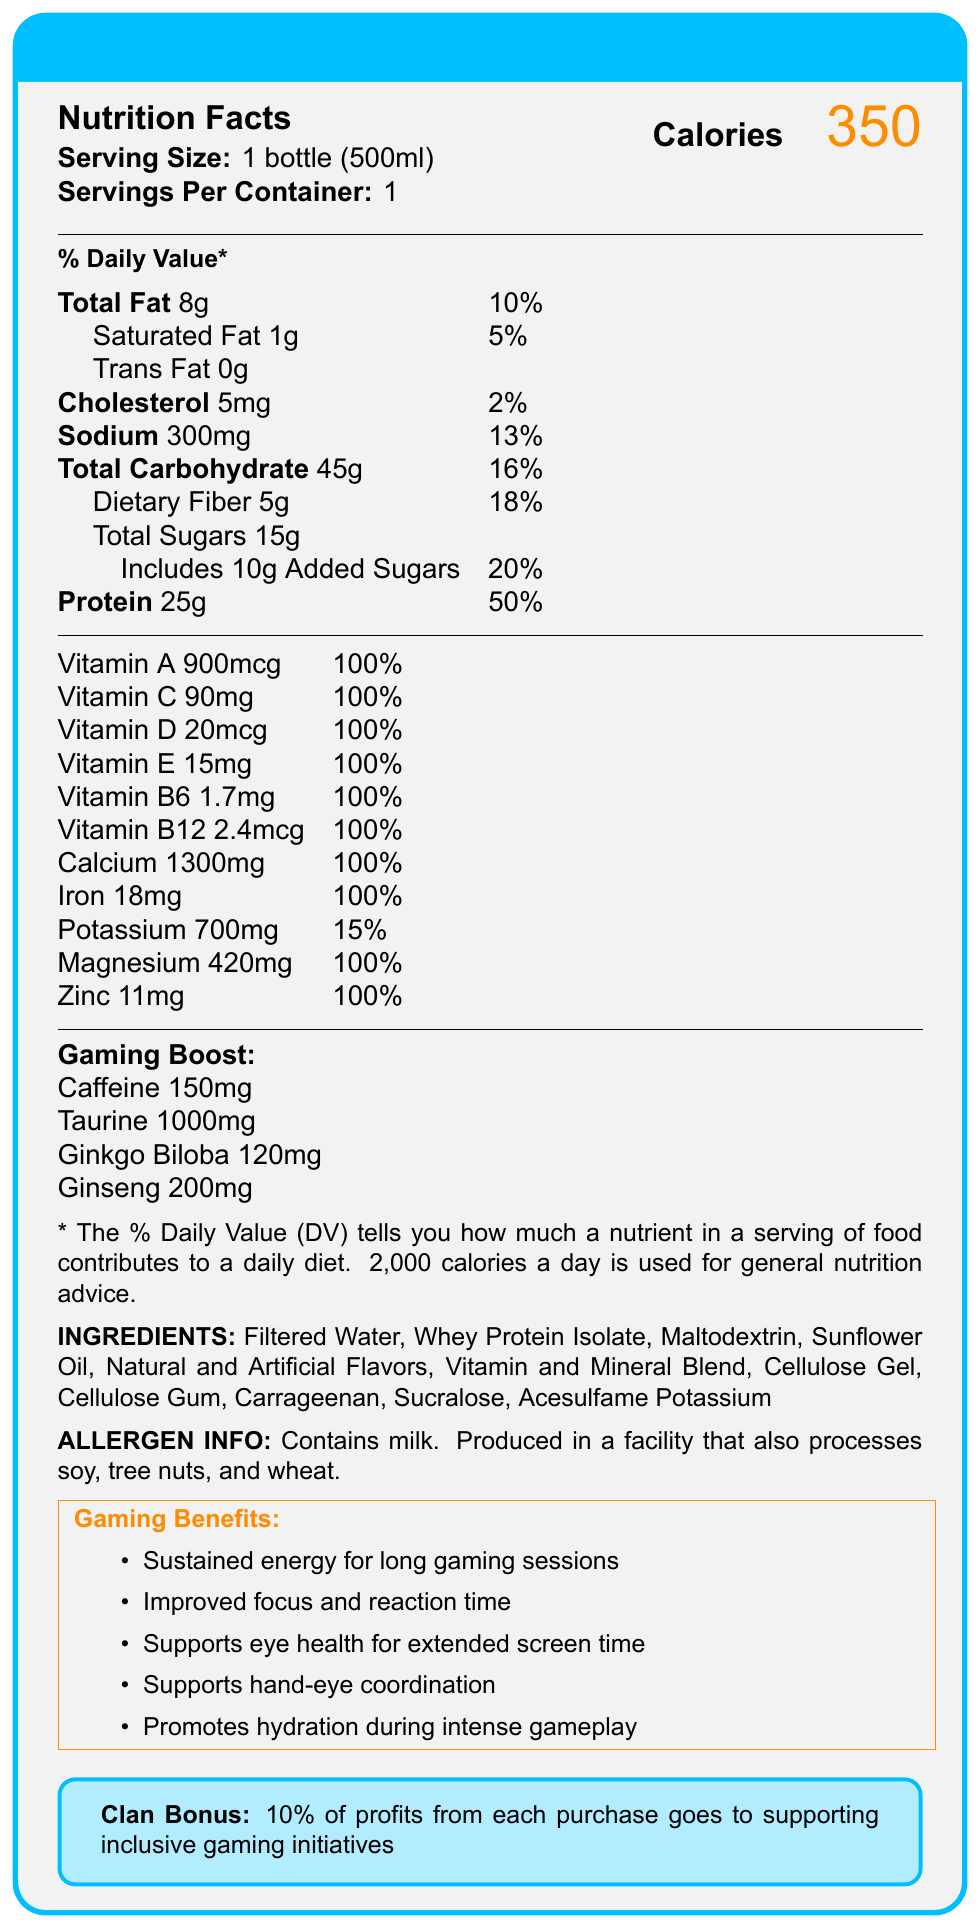what is the product name? The document specifies the product name "GameFuel Ultimate Shake" at the top in the title section.
Answer: GameFuel Ultimate Shake how many calories are in one serving? The document mentions that one serving of GameFuel Ultimate Shake contains 350 calories, highlighted in a large font on the right side.
Answer: 350 what is the serving size of the shake? The serving size is indicated as "1 bottle (500ml)" in the document, under the "Serving Size" section.
Answer: 1 bottle (500ml) how much protein does the shake contain? The document notes that each serving contains 25g of protein, which is 50% of the daily value.
Answer: 25g how much caffeine is in the shake? The shake contains 150mg of caffeine as noted in the "Gaming Boost" section of the document.
Answer: 150mg which vitamin is present at the highest percentage of daily value? A. Vitamin A B. Vitamin C C. Vitamin D D. Vitamin B6 All listed vitamins (A, C, D, E, B6, B12) have 100%, but Vitamin A is the first one listed at 100%.
Answer: A. Vitamin A what are the potential allergens mentioned in the document? A. Soy B. Milk C. Tree nuts D. Wheat E. All of the above The document mentions that the shake "Contains milk" and is "Produced in a facility that also processes soy, tree nuts, and wheat."
Answer: E. All of the above does the shake contain ginseng? The document lists 200mg of ginseng under the "Gaming Boost" section.
Answer: Yes is the shake intended to help with hydration during gaming sessions? One of the gaming benefits mentioned is that the shake "Promotes hydration during intense gameplay."
Answer: Yes what is the total amount of carbohydrates in the shake? The document indicates that the total carbohydrate content is 45g per serving.
Answer: 45g how much of the daily value for dietary fiber does the shake provide? The shake offers 5g of dietary fiber, which accounts for 18% of the daily value as mentioned in the document.
Answer: 18% what are the main benefits of this shake for gamers? The "Gaming Benefits" section lists these specific points as the main benefits for gamers.
Answer: Sustained energy, improved focus, supports eye health, supports hand-eye coordination, promotes hydration which ingredient is present in the highest quantity in the shake? The ingredients list starts with "Filtered Water," which typically indicates it is the main ingredient by quantity.
Answer: Filtered Water how much zinc does the shake contain, and what percentage of the daily value does this amount represent? The document specifies that the shake contains 11mg of zinc, which is 100% of the daily value.
Answer: 11mg, 100% what is the purpose of the "Clan Bonus"? The document mentions that 10% of the profits from each purchase goes to inclusive gaming initiatives under the "Clan Bonus" section.
Answer: To support inclusive gaming initiatives with 10% of profits describe the entire document in a few sentences. The document provides a comprehensive overview of the nutritional content, targeted benefits for gamers, and the mission to support inclusivity within the gaming community.
Answer: The document is a nutrition facts label for the GameFuel Ultimate Shake, a balanced meal replacement shake designed for long gaming sessions. It details the nutritional information, ingredients, allergens, and specific benefits for gamers. Additionally, it highlights a "Clan Bonus" where 10% of profits support inclusive gaming initiatives. does the shake contain any form of sugar? The document mentions "Total Sugars 15g" and includes "10g Added Sugars."
Answer: Yes what is the total amount of magnesium in the shake? The shake contains 420mg of magnesium, which is 100% of the daily value as mentioned in the document.
Answer: 420mg will the caffeine in this shake help with improving focus during gaming? The document lists "Improved focus and reaction time" as one of the gaming benefits, which can be attributed to the caffeine content.
Answer: Yes how is the shake sweetened? The ingredients list includes "Sucralose" and "Acesulfame Potassium" as sweeteners.
Answer: Sucralose and Acesulfame Potassium is there any information about the environmental impact of the shake's packaging? The document does not provide any details on the environmental impact or sustainability of the packaging.
Answer: Not enough information 